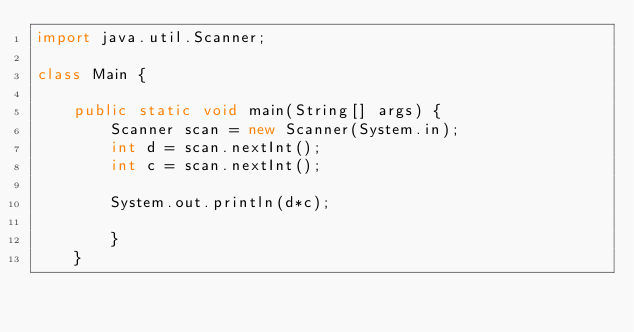Convert code to text. <code><loc_0><loc_0><loc_500><loc_500><_Java_>import java.util.Scanner;

class Main {

    public static void main(String[] args) {
        Scanner scan = new Scanner(System.in);
        int d = scan.nextInt();
        int c = scan.nextInt();
        
        System.out.println(d*c);
          
        }
    }

</code> 